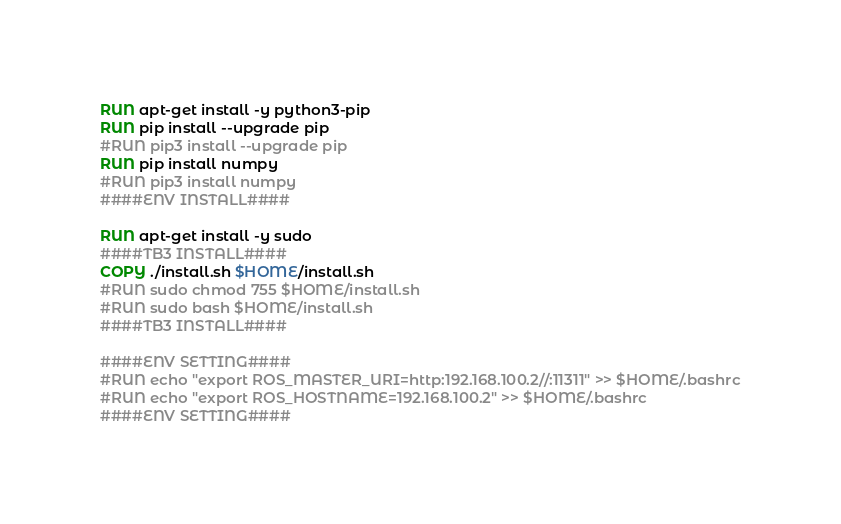Convert code to text. <code><loc_0><loc_0><loc_500><loc_500><_Dockerfile_>RUN apt-get install -y python3-pip
RUN pip install --upgrade pip
#RUN pip3 install --upgrade pip
RUN pip install numpy
#RUN pip3 install numpy
####ENV INSTALL####

RUN apt-get install -y sudo
####TB3 INSTALL####
COPY ./install.sh $HOME/install.sh
#RUN sudo chmod 755 $HOME/install.sh
#RUN sudo bash $HOME/install.sh
####TB3 INSTALL####

####ENV SETTING####
#RUN echo "export ROS_MASTER_URI=http:192.168.100.2//:11311" >> $HOME/.bashrc
#RUN echo "export ROS_HOSTNAME=192.168.100.2" >> $HOME/.bashrc
####ENV SETTING####
</code> 